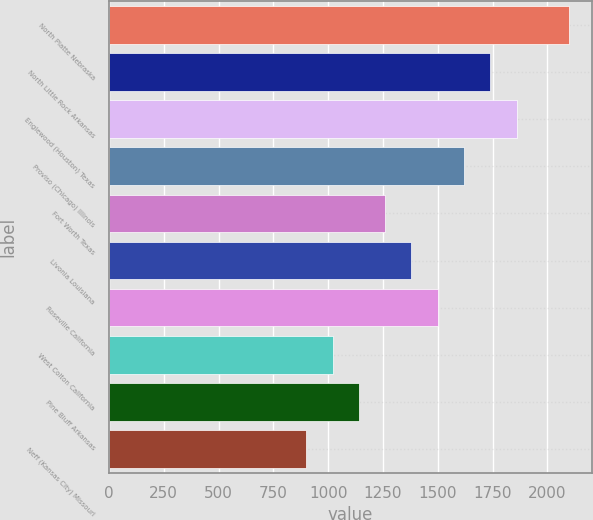<chart> <loc_0><loc_0><loc_500><loc_500><bar_chart><fcel>North Platte Nebraska<fcel>North Little Rock Arkansas<fcel>Englewood (Houston) Texas<fcel>Proviso (Chicago) Illinois<fcel>Fort Worth Texas<fcel>Livonia Louisiana<fcel>Roseville California<fcel>West Colton California<fcel>Pine Bluff Arkansas<fcel>Neff (Kansas City) Missouri<nl><fcel>2100<fcel>1740<fcel>1860<fcel>1620<fcel>1260<fcel>1380<fcel>1500<fcel>1020<fcel>1140<fcel>900<nl></chart> 